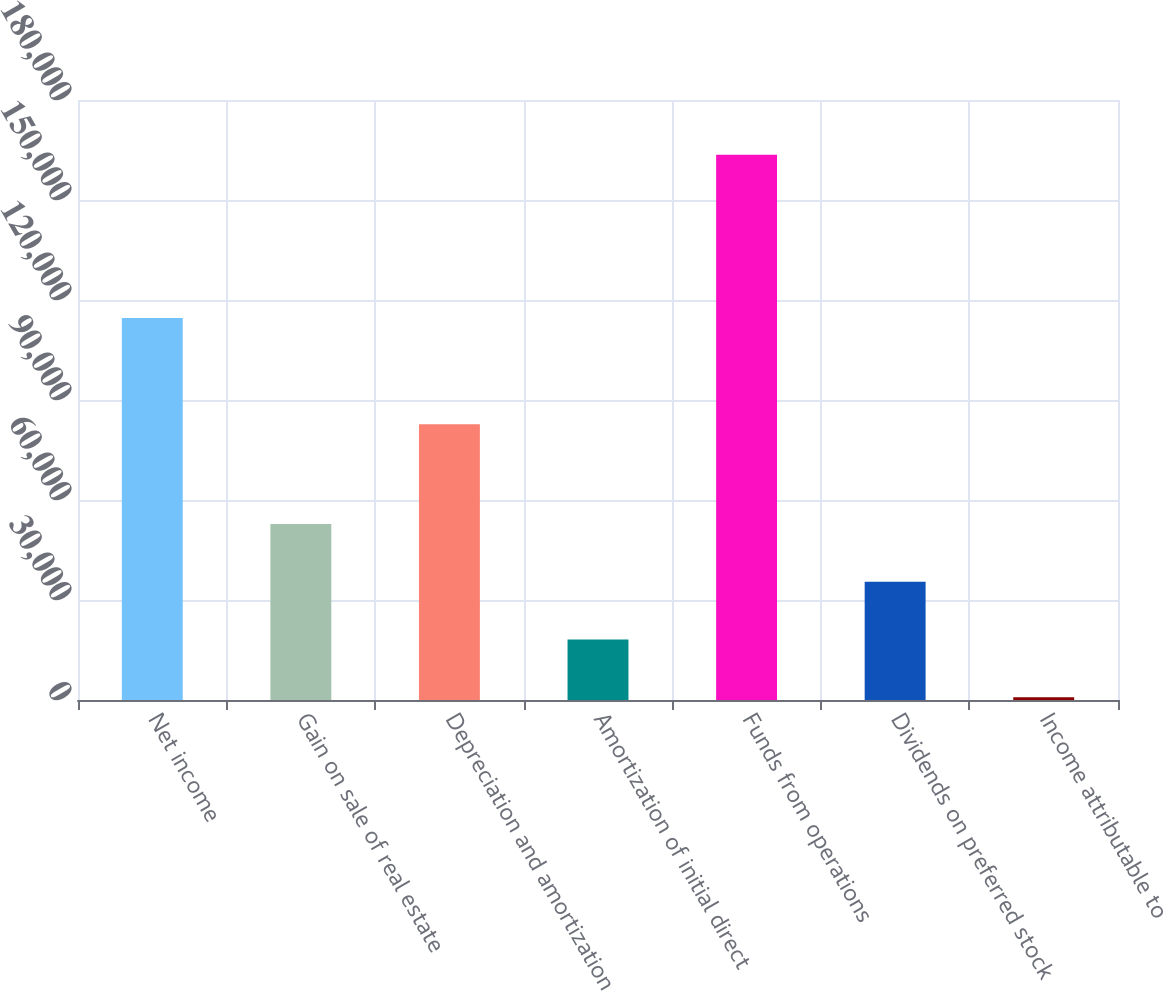Convert chart to OTSL. <chart><loc_0><loc_0><loc_500><loc_500><bar_chart><fcel>Net income<fcel>Gain on sale of real estate<fcel>Depreciation and amortization<fcel>Amortization of initial direct<fcel>Funds from operations<fcel>Dividends on preferred stock<fcel>Income attributable to<nl><fcel>114612<fcel>52826.1<fcel>82752<fcel>18142.7<fcel>163544<fcel>35484.4<fcel>801<nl></chart> 